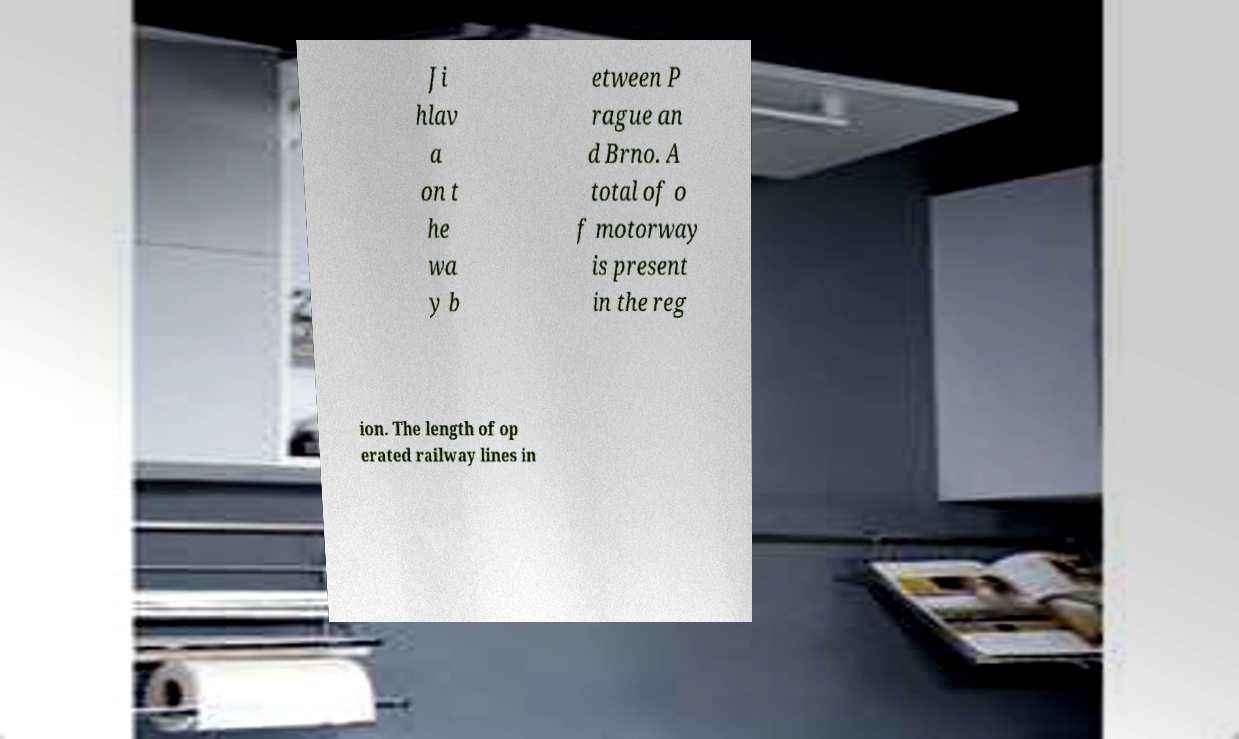Could you extract and type out the text from this image? Ji hlav a on t he wa y b etween P rague an d Brno. A total of o f motorway is present in the reg ion. The length of op erated railway lines in 